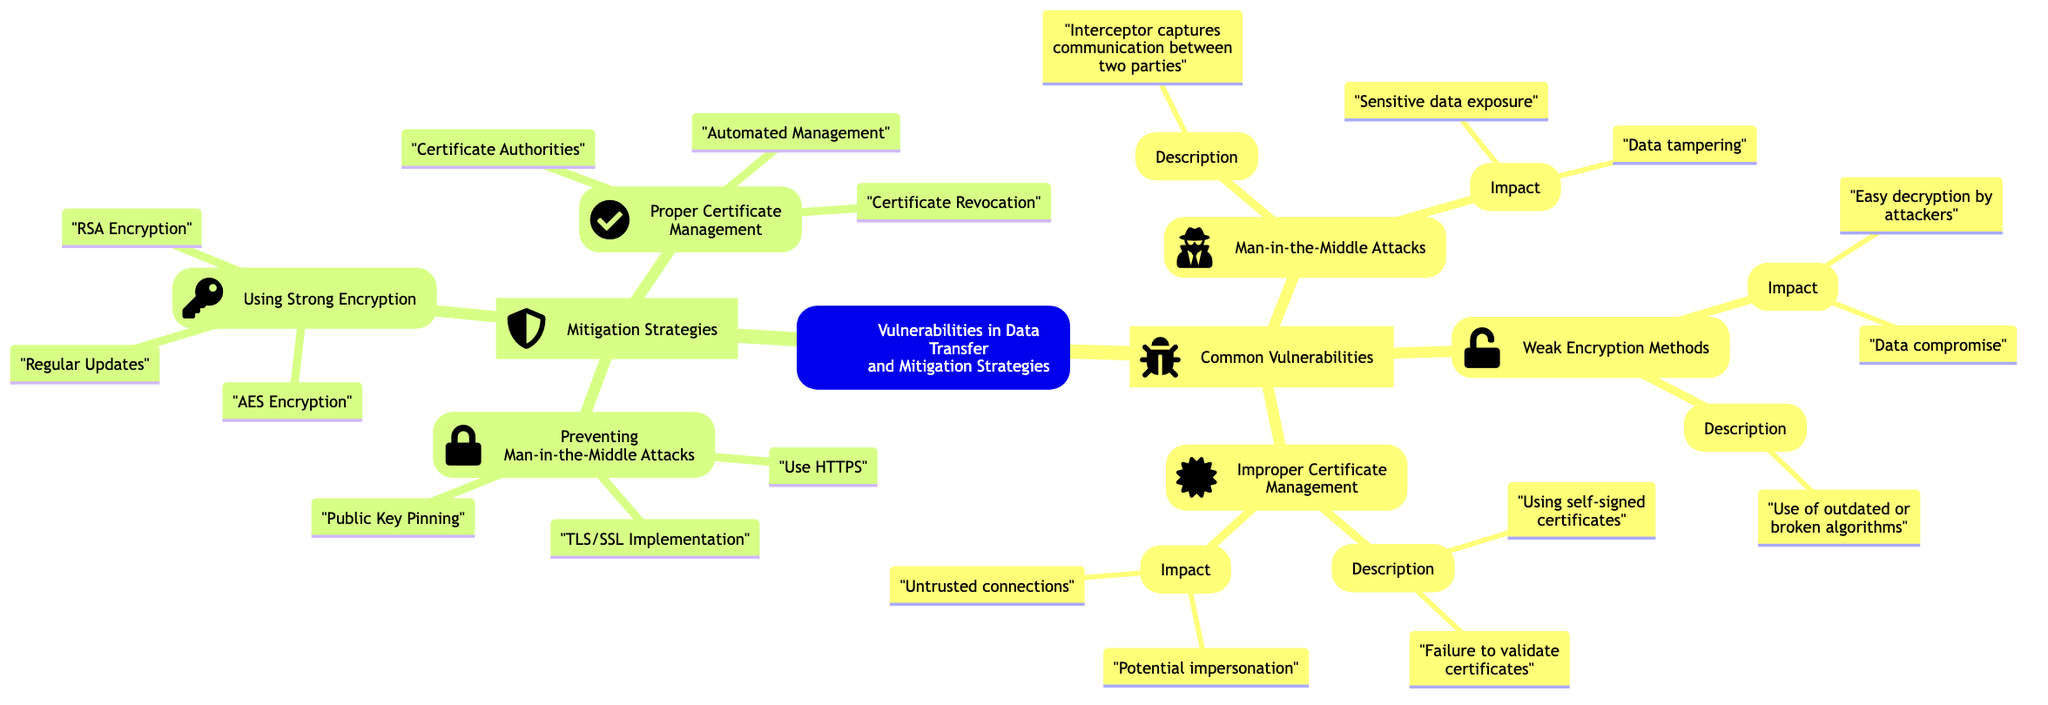What are the three common vulnerabilities listed? The diagram includes three main branches under "Common Vulnerabilities": Man-in-the-Middle Attacks, Weak Encryption Methods, and Improper Certificate Management.
Answer: Man-in-the-Middle Attacks, Weak Encryption Methods, Improper Certificate Management What is one impact of weak encryption methods? Under the "Weak Encryption Methods" subbranch in the diagram, one listed impact is "Easy decryption by attackers," which indicates a direct consequence of using weak encryption.
Answer: Easy decryption by attackers How many mitigation strategies are mentioned? The diagram has one main branch titled "Mitigation Strategies," which further branches out into three specific strategies, indicating there are three key strategies listed.
Answer: Three What is the role of Certificate Authorities in proper certificate management? In the section titled "Proper Certificate Management," one of the subbranches describes "Certificate Authorities" as entities that should be trusted and regularly updated, suggesting their importance in maintaining secure communications.
Answer: Use trusted CAs, regularly update certificates What are the three methods to prevent man-in-the-middle attacks? Under "Preventing Man-in-the-Middle Attacks," the diagram lists three methods: Use HTTPS, TLS/SSL Implementation, and Public Key Pinning, which are crucial for securing data transfer.
Answer: Use HTTPS, TLS/SSL Implementation, Public Key Pinning What is the relationship between weak encryption methods and data compromise? The diagram shows a direct relationship by indicating that "Easy decryption by attackers" and "Data compromise" are two impacts under the "Weak Encryption Methods" subbranch, suggesting that weak encryption leads to data being compromised.
Answer: Easy decryption leads to data compromise What is a necessary step for proper certificate management? The diagram suggests "Enable Certificate Revocation Lists (CRLs)" as a step in the subbranch for "Proper Certificate Management," indicating the importance of maintaining trust in certificates.
Answer: Enable Certificate Revocation Lists (CRLs) Which encryption method is recommended for strong data encryption? The diagram specifically mentions "AES Encryption" under the subbranch "Using Strong Encryption," indicating it as a recommended method for securing data.
Answer: AES Encryption 